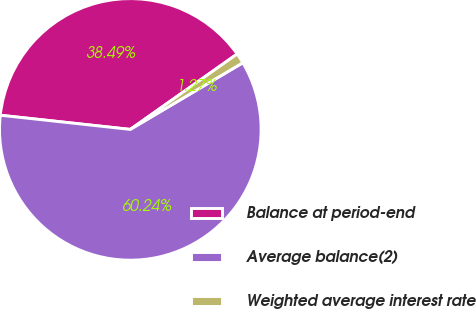<chart> <loc_0><loc_0><loc_500><loc_500><pie_chart><fcel>Balance at period-end<fcel>Average balance(2)<fcel>Weighted average interest rate<nl><fcel>38.49%<fcel>60.24%<fcel>1.27%<nl></chart> 